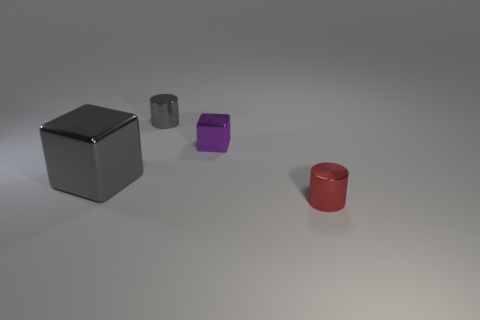Are the smaller objects also cubes, and do they have the same color? The smaller objects are not cubes; they are cylindrical. One is purple, and the other is red, so they each have a different color from each other and from the gray cube. 